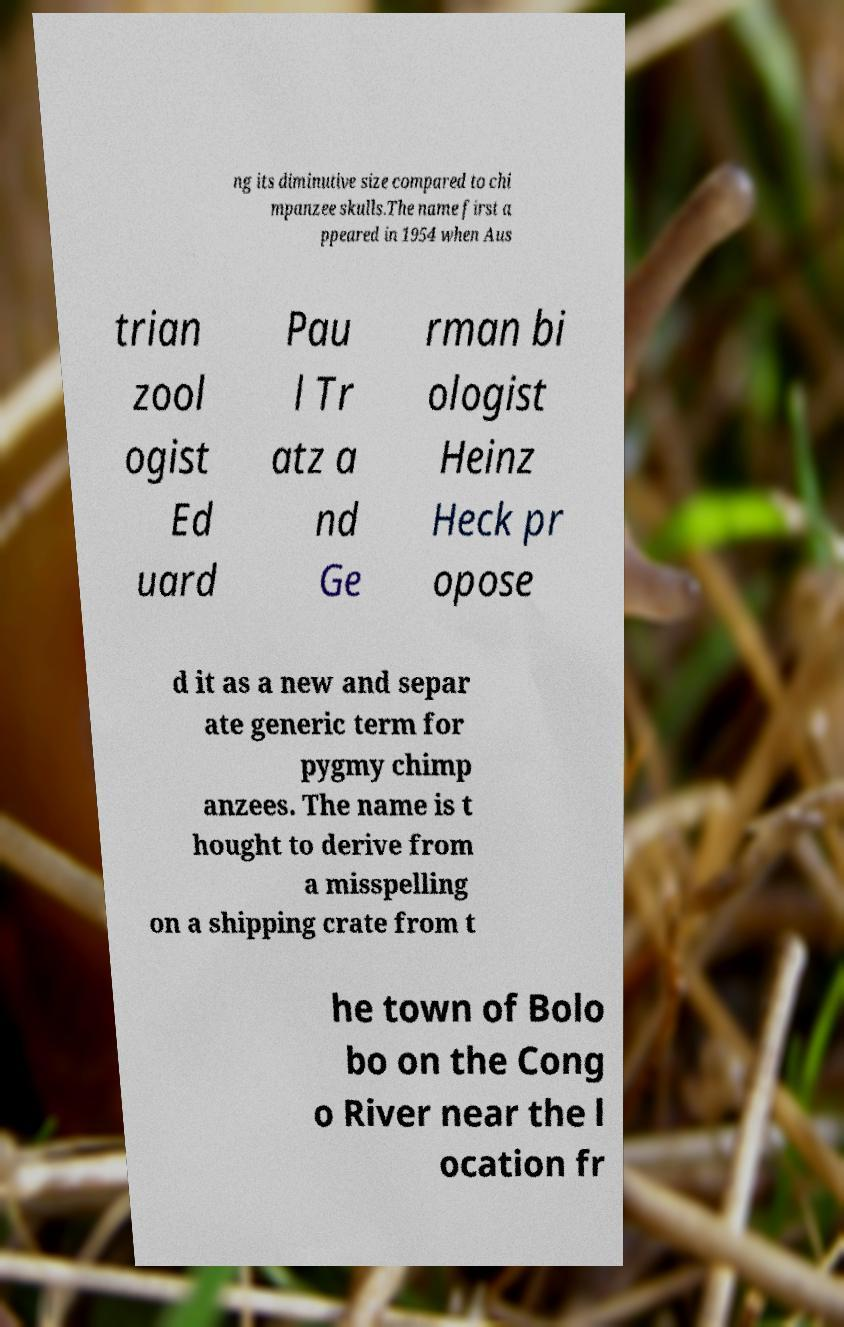Could you extract and type out the text from this image? ng its diminutive size compared to chi mpanzee skulls.The name first a ppeared in 1954 when Aus trian zool ogist Ed uard Pau l Tr atz a nd Ge rman bi ologist Heinz Heck pr opose d it as a new and separ ate generic term for pygmy chimp anzees. The name is t hought to derive from a misspelling on a shipping crate from t he town of Bolo bo on the Cong o River near the l ocation fr 